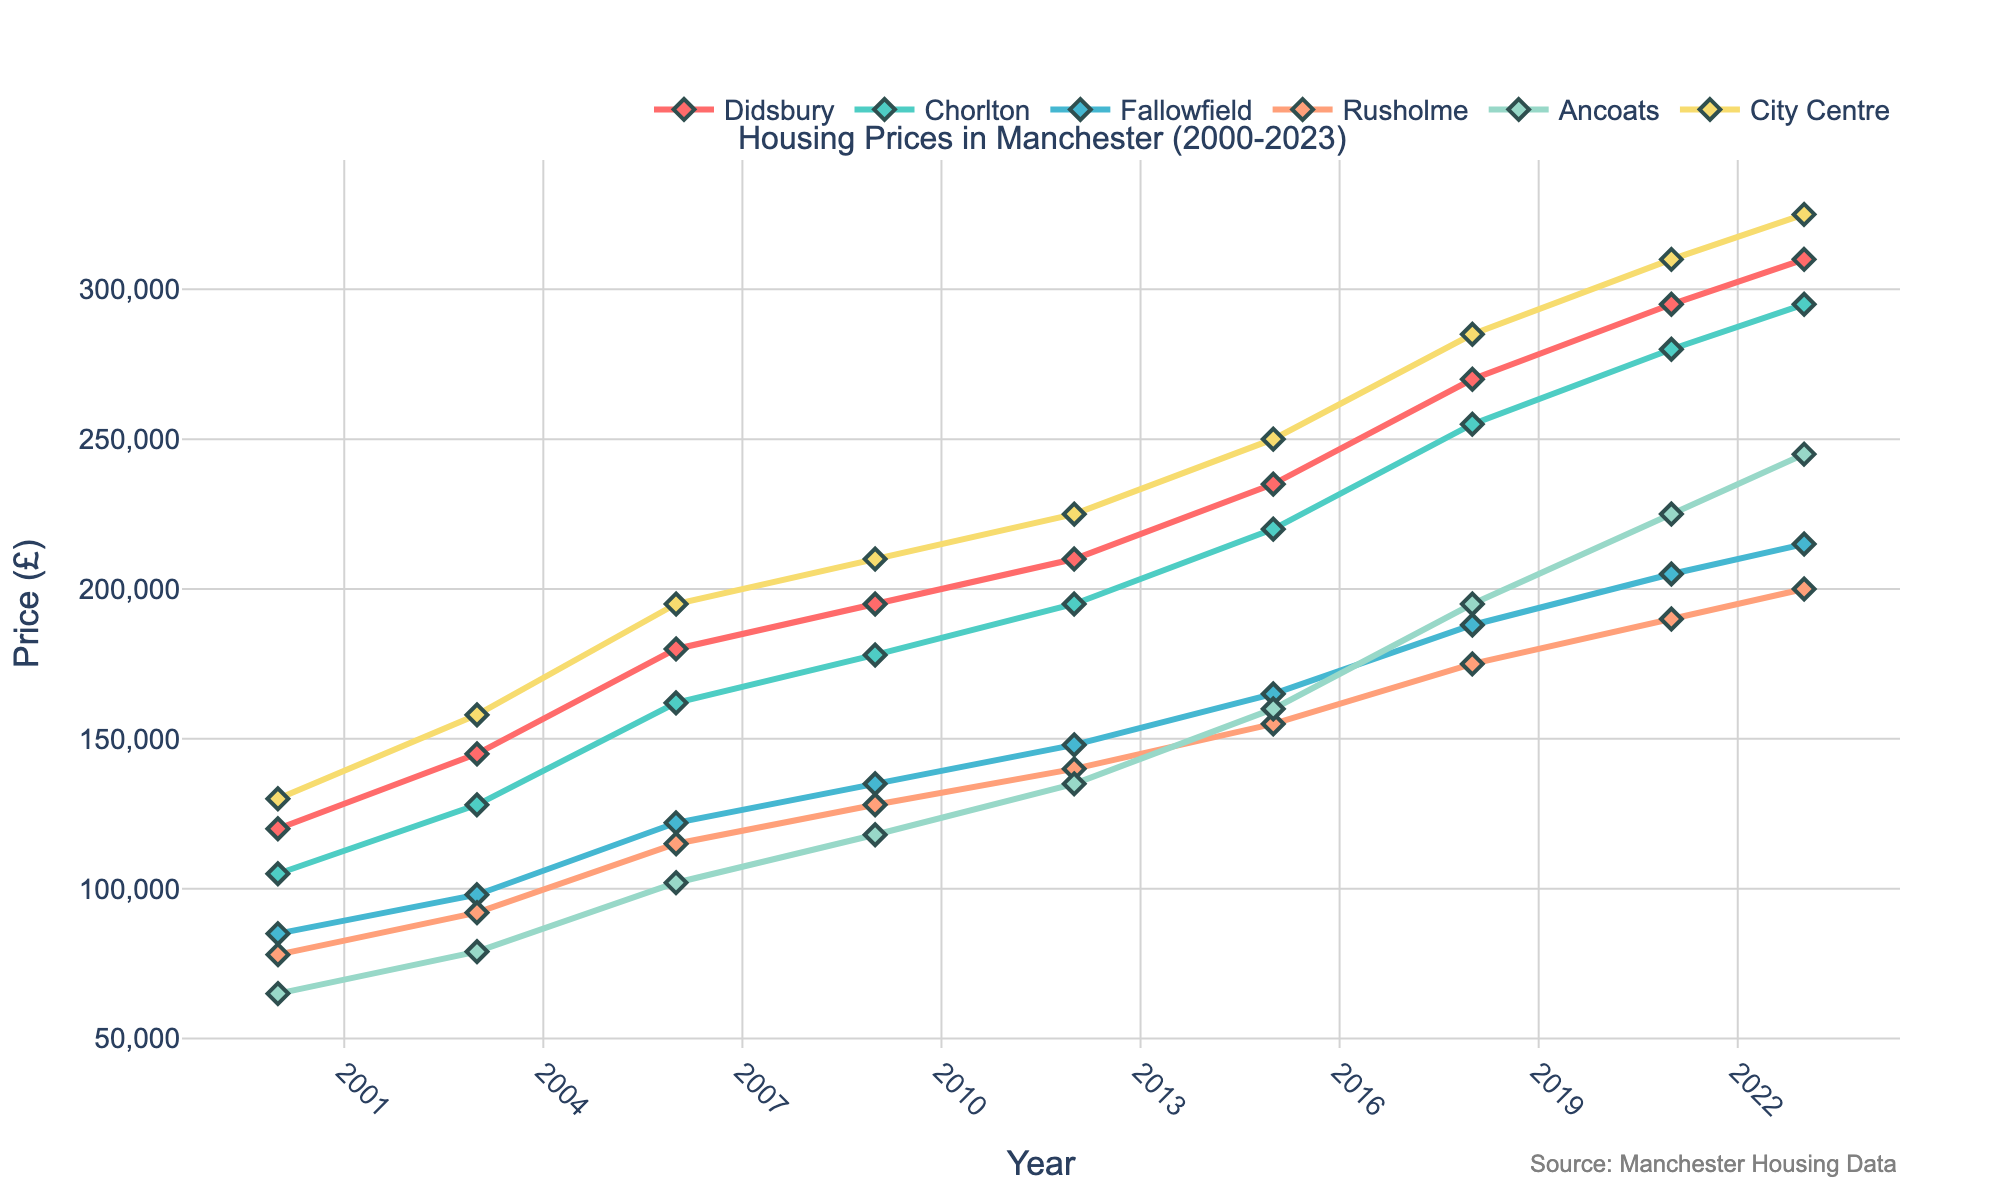What's the trend for housing prices in Didsbury from 2000 to 2023? The trend for housing prices in Didsbury shows a consistent increase from £120,000 in 2000 to £310,000 in 2023. Each data point in the line chart gradually rises year by year.
Answer: Consistent increase Which neighborhood experienced the highest growth in housing prices between 2000 and 2023? By comparing the starting and ending values for each neighborhood, City Centre had the highest growth. It went from £130,000 in 2000 to £325,000 in 2023, an increase of £195,000.
Answer: City Centre In which year did Rusholme's housing prices first exceed £150,000? Refer to the specific points for Rusholme and observe their values. In 2015, the price is £155,000, which is the first instance exceeding £150,000.
Answer: 2015 How do the housing prices in Chorlton compare with those in Ancoats in 2023? By looking at the height of the lines in 2023, Chorlton's housing price is £295,000, and Ancoats's is £245,000. Therefore, Chorlton's prices are higher.
Answer: Chorlton's are higher What is the average housing price in Fallowfield over the given period? Sum up all the values for Fallowfield and divide by the number of time points: (85000 + 98000 + 122000 + 135000 + 148000 + 165000 + 188000 + 205000 + 215000) / 9 = 150000
Answer: £150,000 How much did the housing prices in Ancoats increase from 2018 to 2023? In 2018, the price in Ancoats was £195,000, and in 2023 it was £245,000. The difference is £245,000 - £195,000 = £50,000.
Answer: £50,000 Which neighborhood had the smallest increase in housing prices between 2000 and 2023? Calculate the increase for each neighborhood: Didsbury: £310,000 - £120,000 = £190,000, Chorlton: £295,000 - £105,000 = £190,000, Fallowfield: £215,000 - £85,000 = £130,000, Rusholme: £200,000 - £78,000 = £122,000, Ancoats: £245,000 - £65,000 = £180,000, City Centre: £325,000 - £130,000 = £195,000. Rusholme had the smallest increase of £122,000.
Answer: Rusholme Compare the housing prices trend of Fallowfield and Rusholme from 2000 to 2023. Both neighborhoods generally show an upward trend. Fallowfield started at £85,000 and ended at £215,000, while Rusholme started at £78,000 and ended at £200,000. Fallowfield's prices are consistently higher than Rusholme's, and both have similar growth rates over the years.
Answer: Both increasing, Fallowfield consistently higher What is the price difference between Didsbury and City Centre in 2021? In 2021, the housing price in Didsbury is £295,000 and in the City Centre is £310,000. The difference is £310,000 - £295,000 = £15,000.
Answer: £15,000 